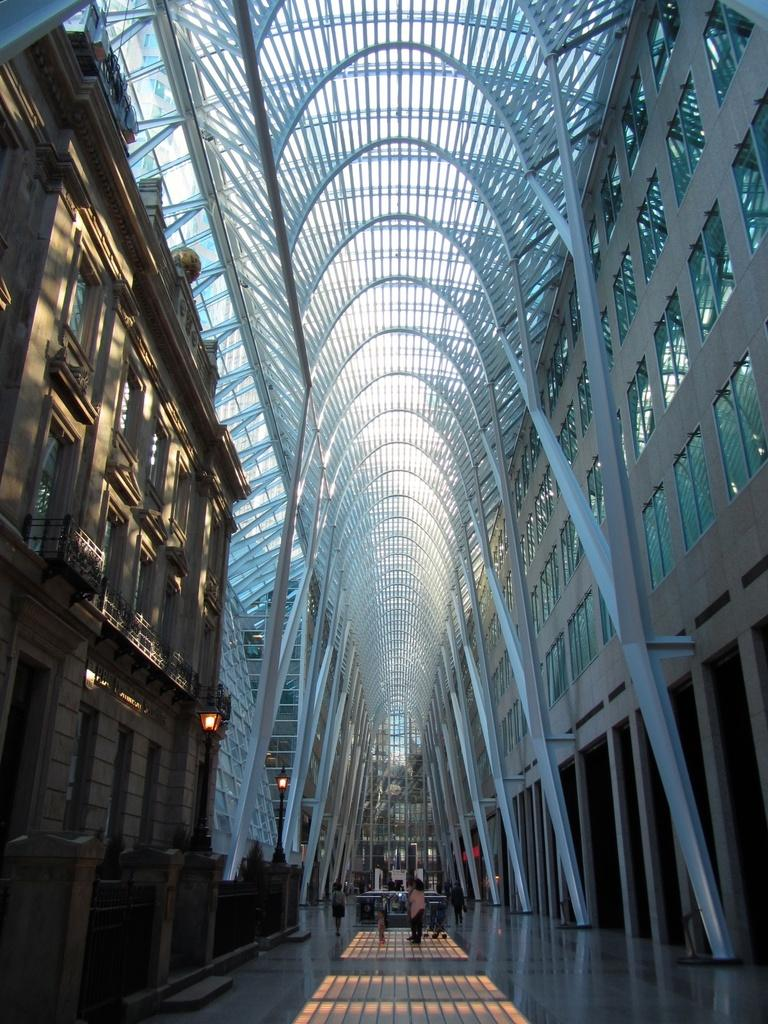What type of structures can be seen in the image? There are buildings in the image. Where are the people located in the image? The people are in the middle of the image. What is present on the left side of the image? There are lights on the left side of the image. What material can be seen at the top of the image? There are metal rods at the top of the image. Can you tell me how many flowers are growing on the metal rods in the image? There are no flowers present on the metal rods in the image. What type of glue is being used to hold the lights together in the image? There is no glue visible in the image, and the lights are not shown to be held together. 